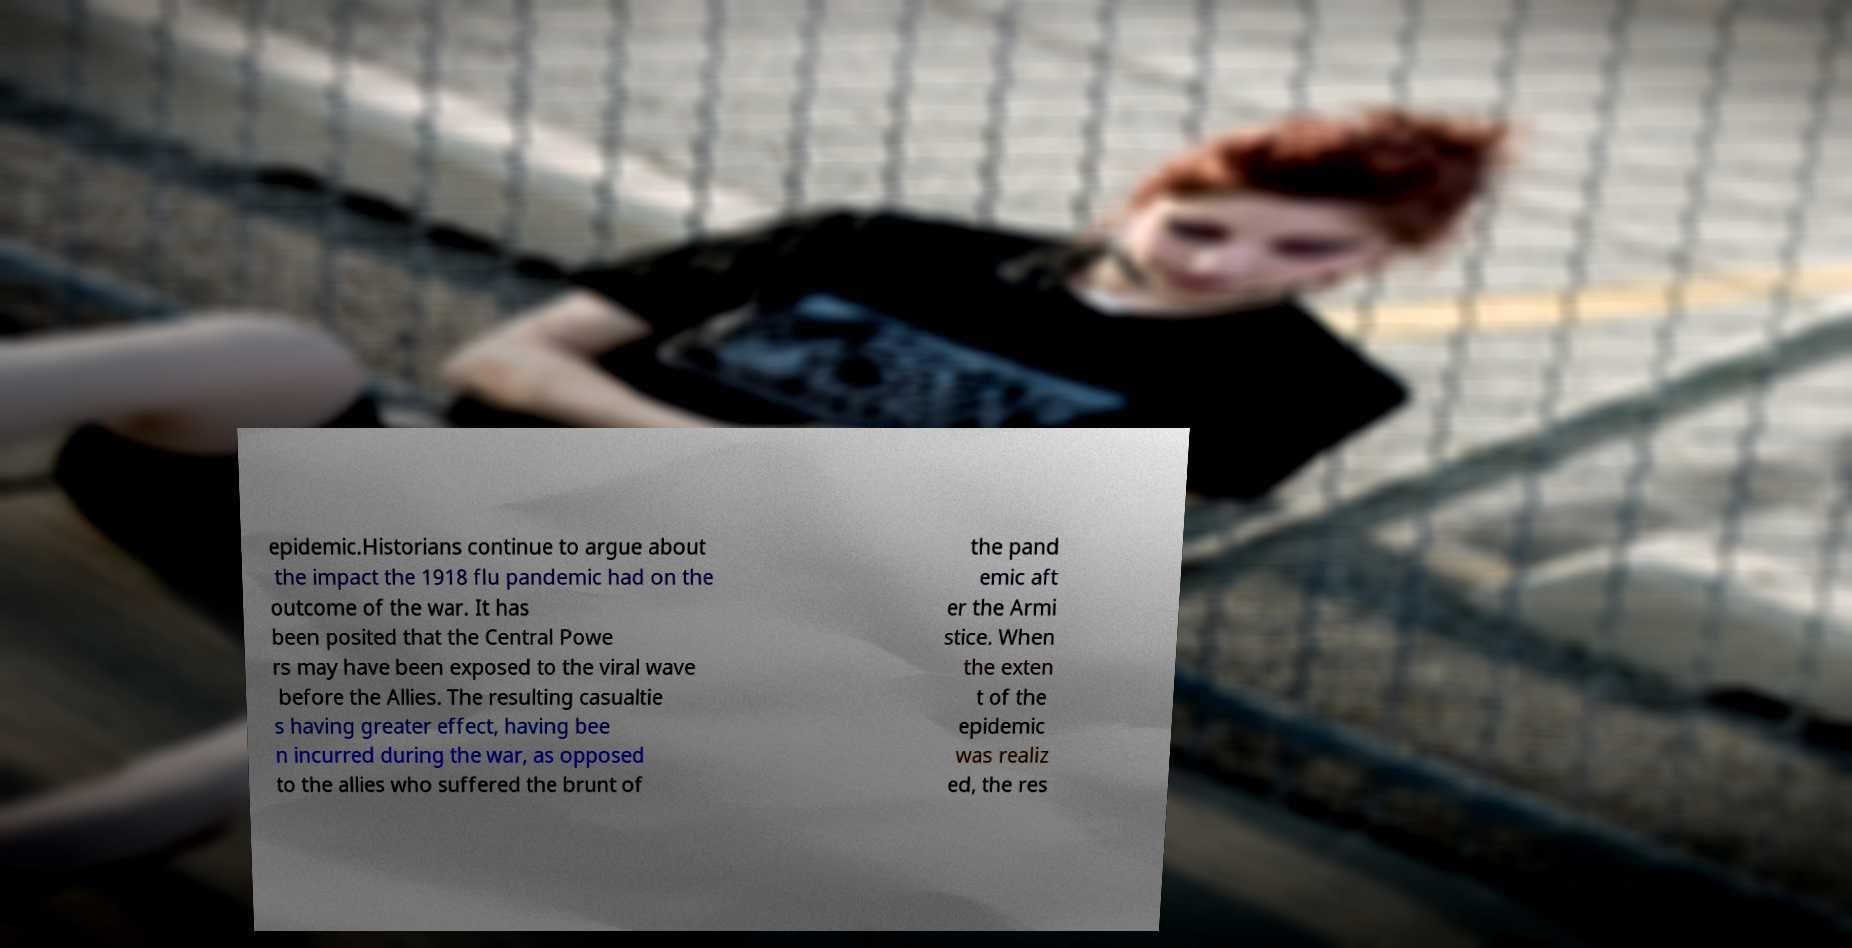I need the written content from this picture converted into text. Can you do that? epidemic.Historians continue to argue about the impact the 1918 flu pandemic had on the outcome of the war. It has been posited that the Central Powe rs may have been exposed to the viral wave before the Allies. The resulting casualtie s having greater effect, having bee n incurred during the war, as opposed to the allies who suffered the brunt of the pand emic aft er the Armi stice. When the exten t of the epidemic was realiz ed, the res 